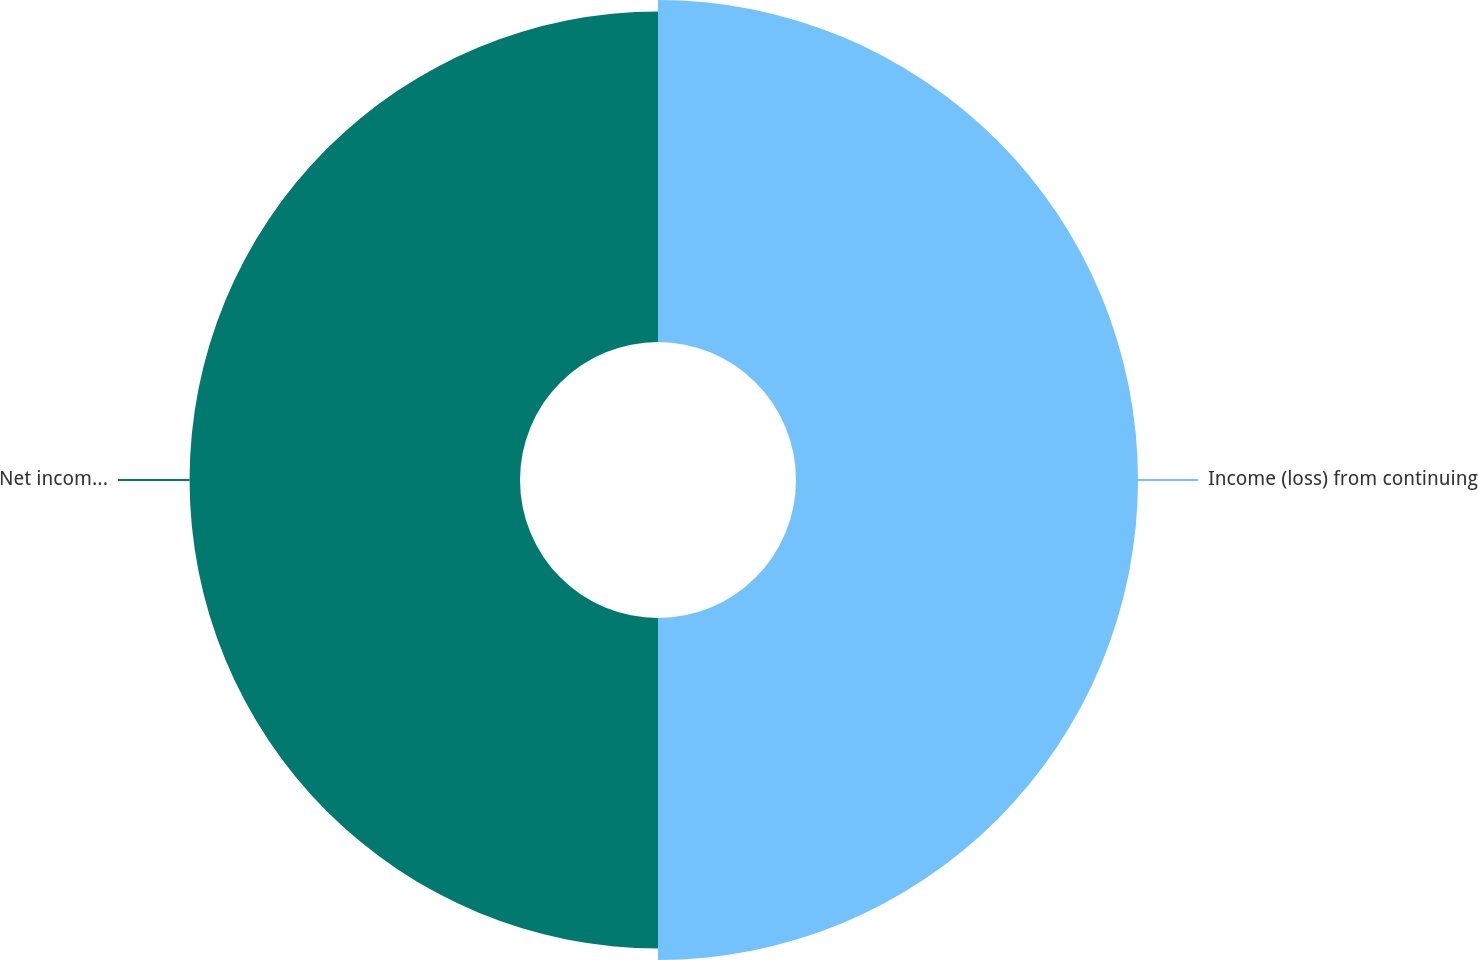Convert chart to OTSL. <chart><loc_0><loc_0><loc_500><loc_500><pie_chart><fcel>Income (loss) from continuing<fcel>Net income (loss)<nl><fcel>50.86%<fcel>49.14%<nl></chart> 